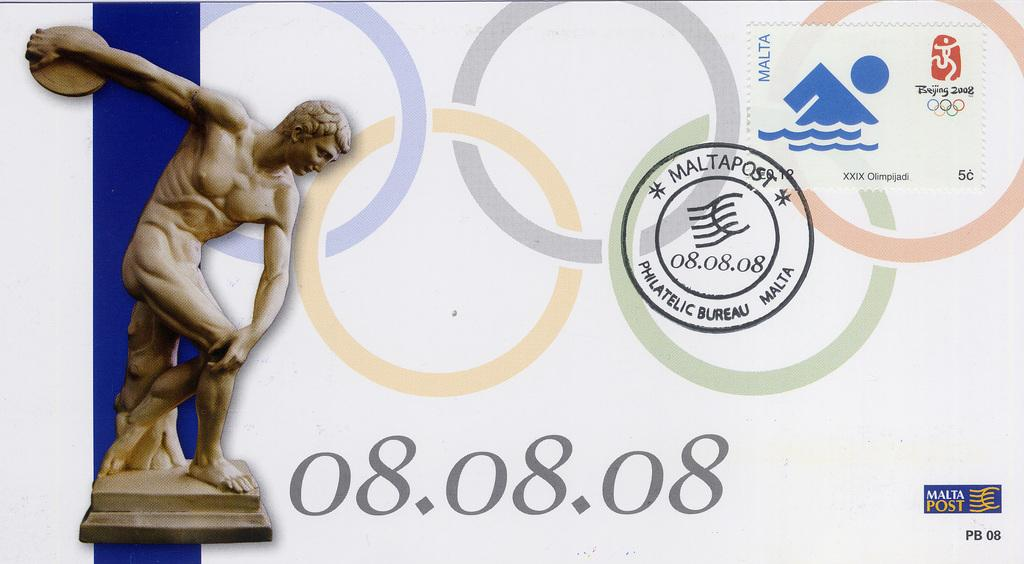What can be seen on the left side of the image? There is a person sculpture on the left side of the image. What is located in the middle of the image? There is text and design visible in the middle of the image. What type of veil is draped over the person sculpture in the image? There is no veil present in the image; it features a person sculpture and text and design in the middle. How many apples are visible in the image? There are no apples present in the image. 